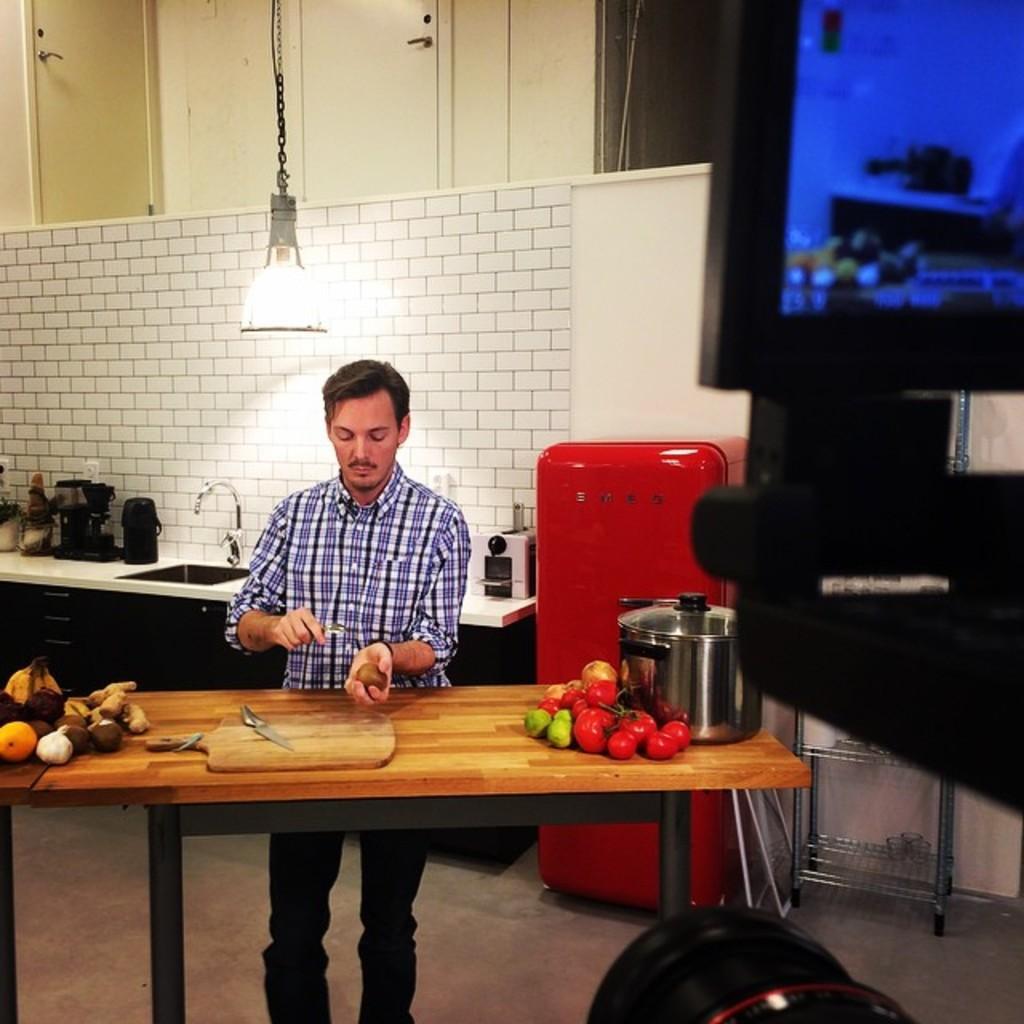How would you summarize this image in a sentence or two? Here we can see a man who is standing on the floor. This is table. On the table there are fruits. This is knife. On the background there is wall and this is light. 